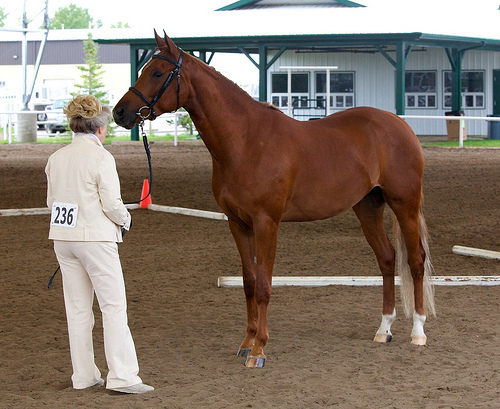<image>
Is there a man on the horse? No. The man is not positioned on the horse. They may be near each other, but the man is not supported by or resting on top of the horse. Is the woman in front of the horse? Yes. The woman is positioned in front of the horse, appearing closer to the camera viewpoint. 